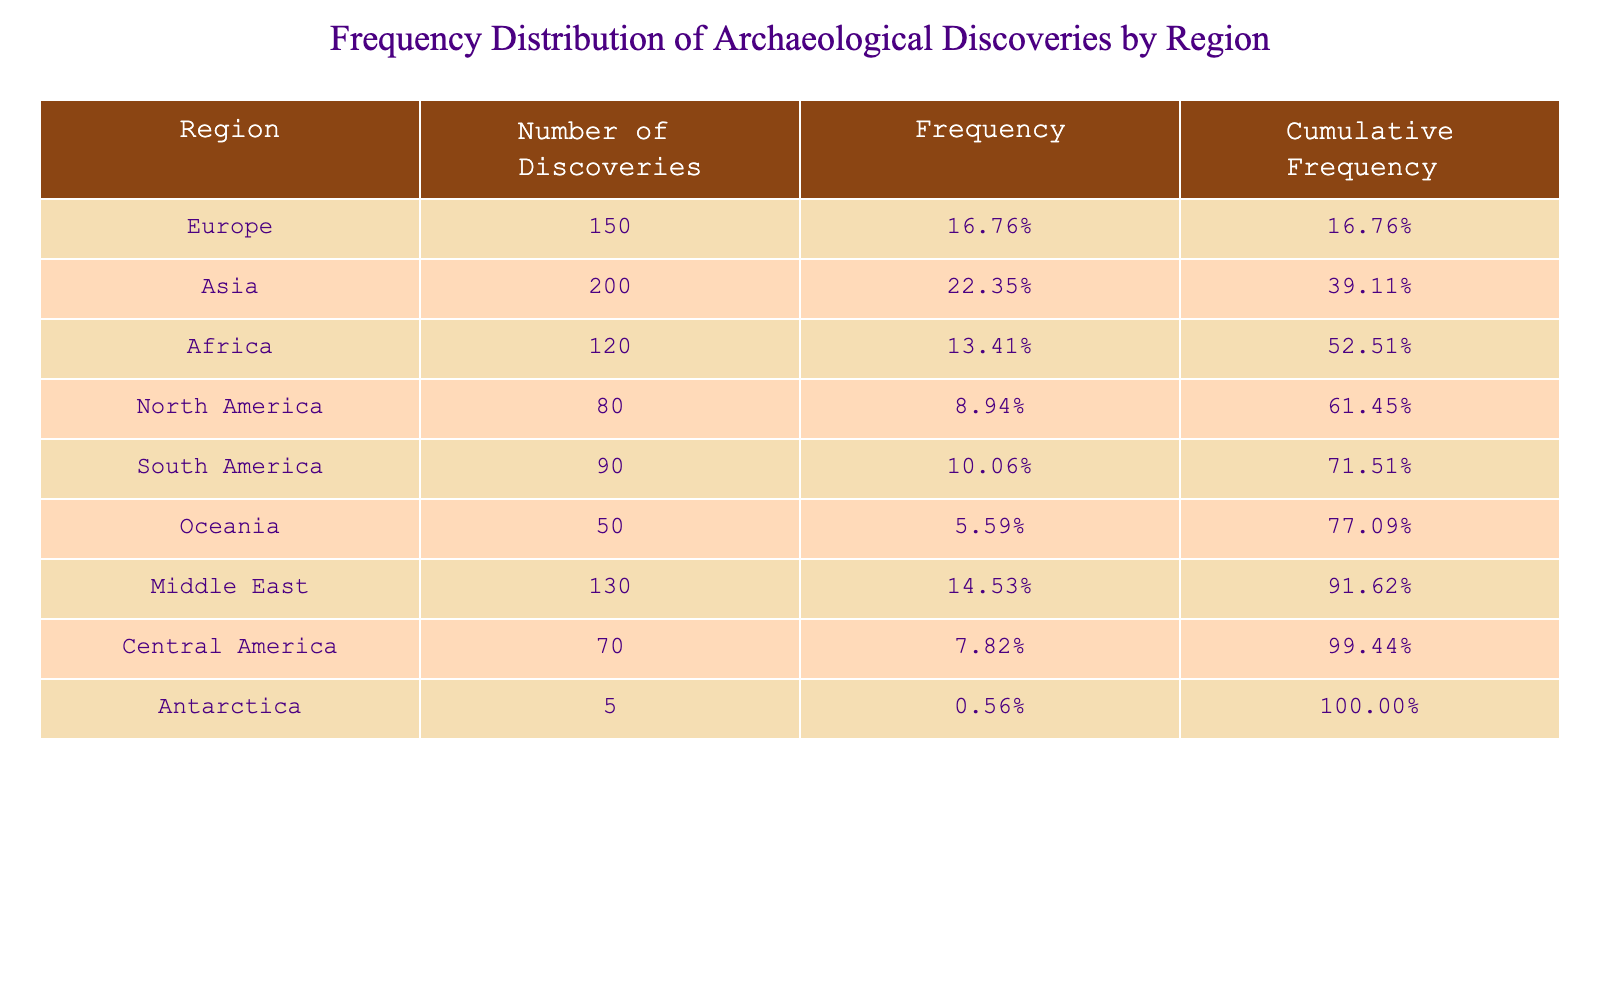What region has the highest number of discoveries? By observing the "Number of Discoveries" column, we can see that Asia has the highest number, which is 200.
Answer: Asia What is the total number of archaeological discoveries across all regions? By summing up the "Number of Discoveries" for each region: 150 + 200 + 120 + 80 + 90 + 50 + 130 + 70 + 5 = 915.
Answer: 915 Which region has the lowest number of discoveries? From the "Number of Discoveries" column, we identify that Antarctica has the lowest number, with only 5 discoveries.
Answer: Antarctica What percentage of the total discoveries does North America represent? The total discoveries are 915. North America's discoveries are 80. So, the percentage is calculated as (80 / 915) * 100 ≈ 8.74%.
Answer: Approximately 8.74% Is the number of discoveries in South America greater than that in Oceania? South America's number of discoveries is 90, while Oceania's is 50. Since 90 is greater than 50, the statement is true.
Answer: Yes What is the cumulative frequency for Africa? To find the cumulative frequency for Africa, we first find its frequency: 120 / 915 ≈ 0.1315 or 13.15%. Then, we must add the frequencies of the regions above Africa: Europe (150/915), Asia (200/915), and Middle East (130/915). Summing these frequencies gives us about 0.1315 + 0.1648 + 0.2185 + 0.1429 = 0.8577 or 85.77%.
Answer: Approximately 85.77% How many more discoveries were made in Asia compared to South America? The number of discoveries in Asia is 200, and in South America is 90. The difference is calculated as 200 - 90 = 110 discoveries.
Answer: 110 Which two regions combined have a number of discoveries larger than that of Europe? Europe has 150 discoveries. Combining Africa (120) and Middle East (130) gives us 120 + 130 = 250, which is greater than 150. Therefore, Africa and Middle East together exceed Europe's discoveries.
Answer: Africa and Middle East What percentage of discoveries does Oceania account for? Oceania's discoveries are 50, and the total is 915. The percentage can be calculated as (50 / 915) * 100 ≈ 5.47%.
Answer: Approximately 5.47% 